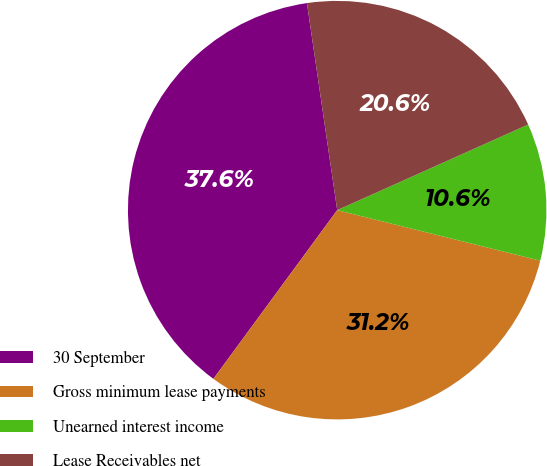Convert chart. <chart><loc_0><loc_0><loc_500><loc_500><pie_chart><fcel>30 September<fcel>Gross minimum lease payments<fcel>Unearned interest income<fcel>Lease Receivables net<nl><fcel>37.61%<fcel>31.19%<fcel>10.59%<fcel>20.6%<nl></chart> 